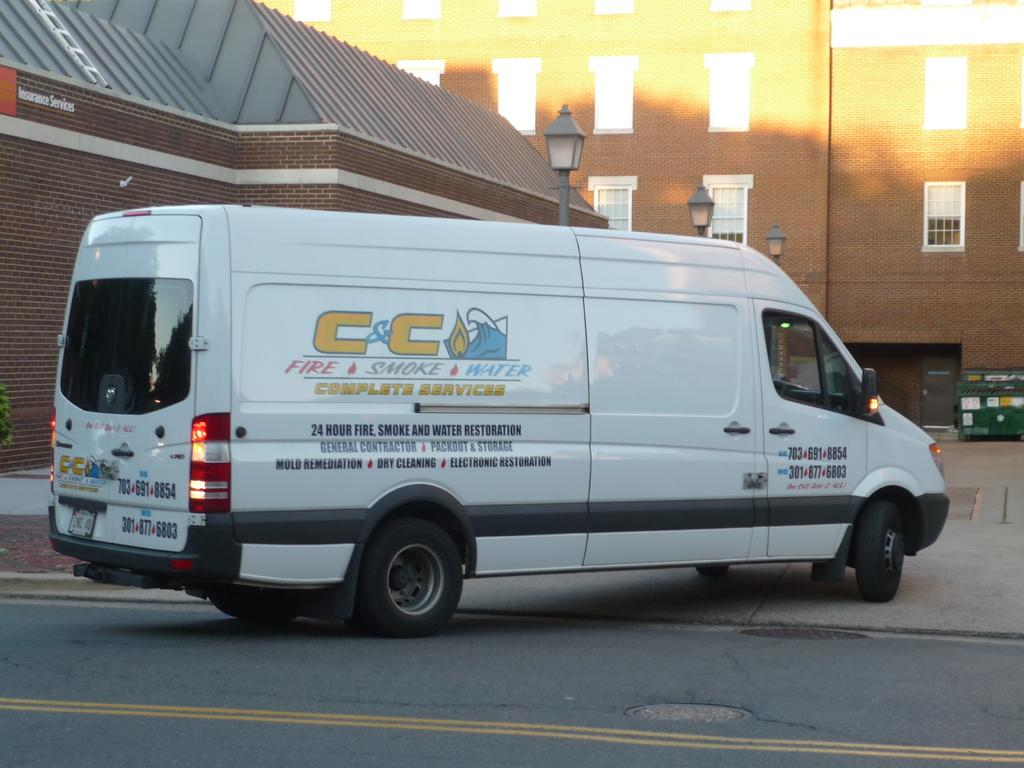What is the main subject of the image? There is a vehicle on the road in the image. What can be seen in the distance behind the vehicle? There are buildings and light poles in the background of the image. Can you hear the vehicle's engine crying in the image? There is no sound in the image, so it is not possible to determine if the vehicle's engine is making any noise, let alone crying. 